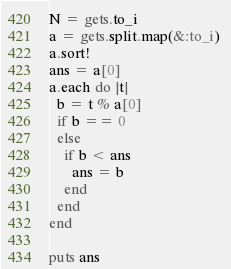Convert code to text. <code><loc_0><loc_0><loc_500><loc_500><_Ruby_>N = gets.to_i
a = gets.split.map(&:to_i) 
a.sort!
ans = a[0]
a.each do |t|
  b = t % a[0]
  if b == 0
  else
    if b < ans
      ans = b
    end
  end
end

puts ans</code> 